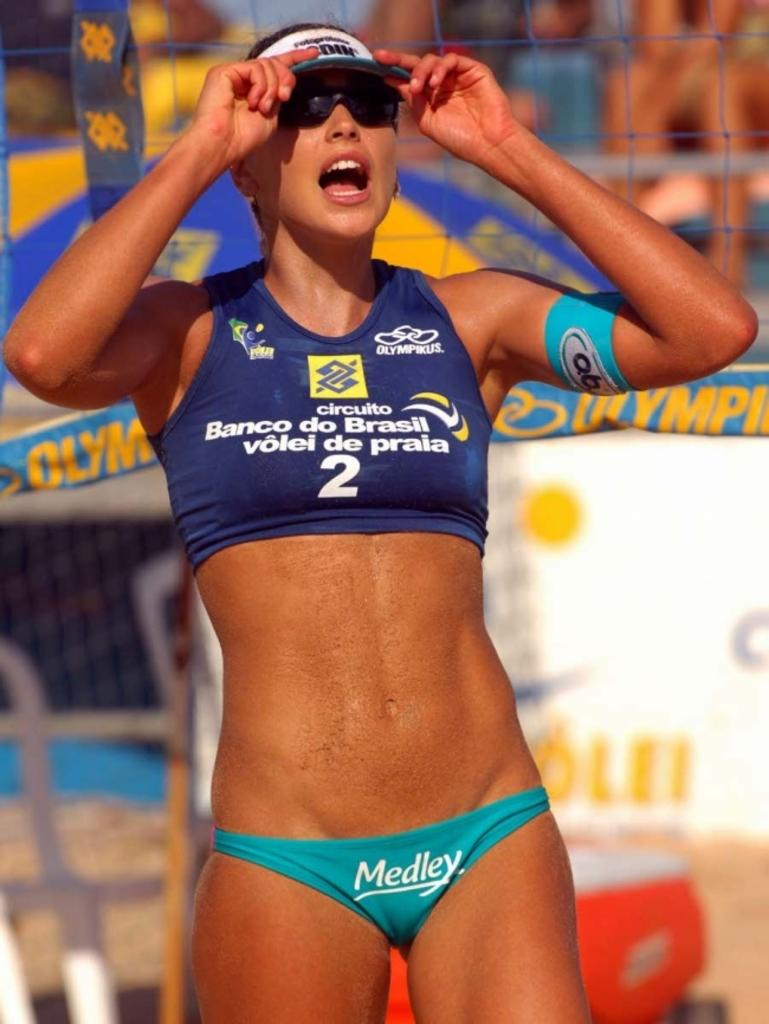<image>
Provide a brief description of the given image. a lady with the number 2 on her volleyball outfit outside 